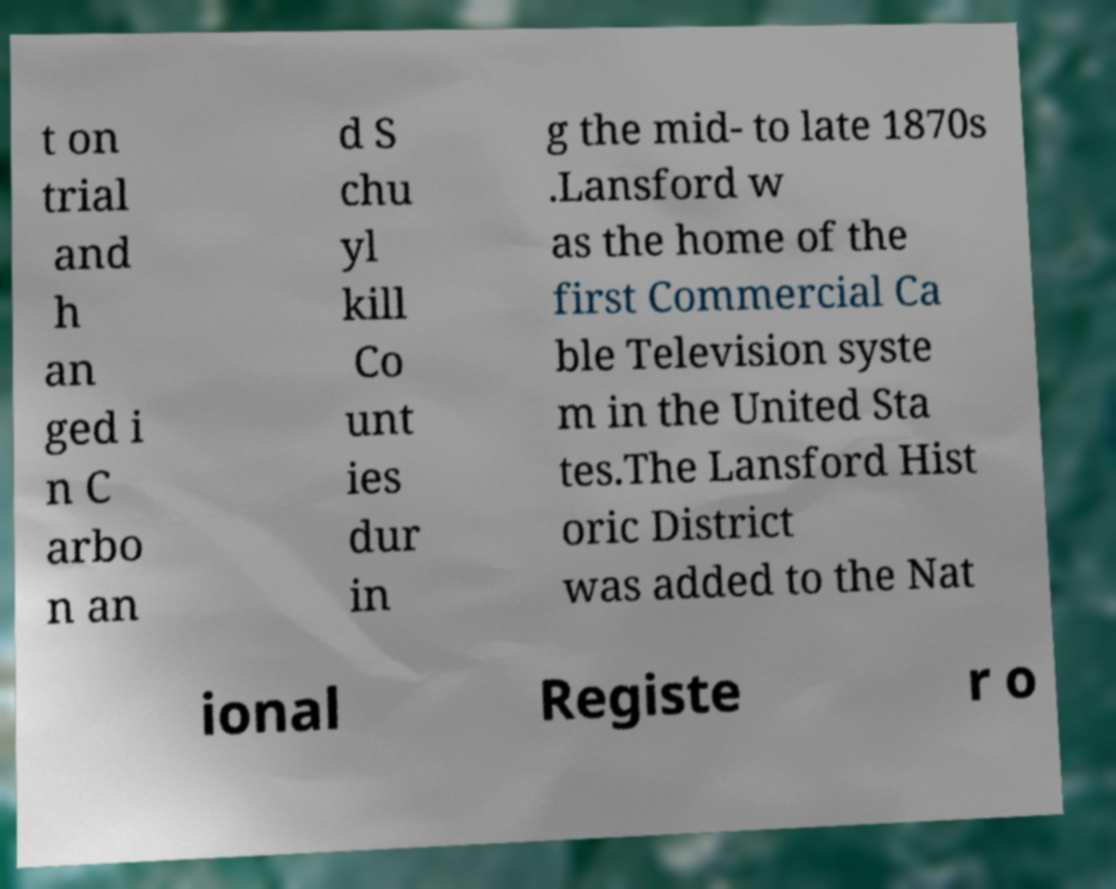What messages or text are displayed in this image? I need them in a readable, typed format. t on trial and h an ged i n C arbo n an d S chu yl kill Co unt ies dur in g the mid- to late 1870s .Lansford w as the home of the first Commercial Ca ble Television syste m in the United Sta tes.The Lansford Hist oric District was added to the Nat ional Registe r o 